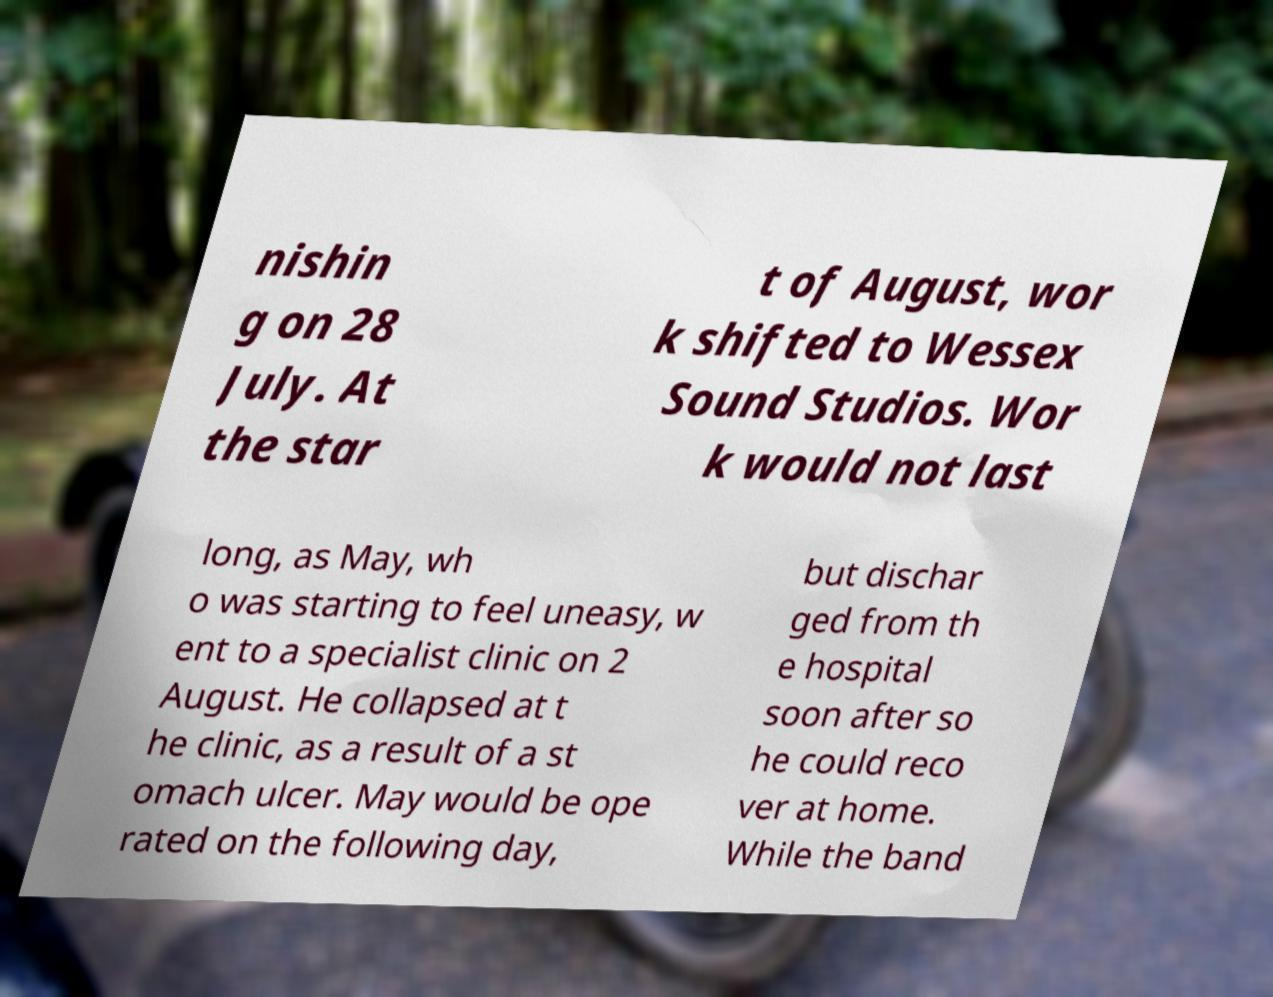I need the written content from this picture converted into text. Can you do that? nishin g on 28 July. At the star t of August, wor k shifted to Wessex Sound Studios. Wor k would not last long, as May, wh o was starting to feel uneasy, w ent to a specialist clinic on 2 August. He collapsed at t he clinic, as a result of a st omach ulcer. May would be ope rated on the following day, but dischar ged from th e hospital soon after so he could reco ver at home. While the band 